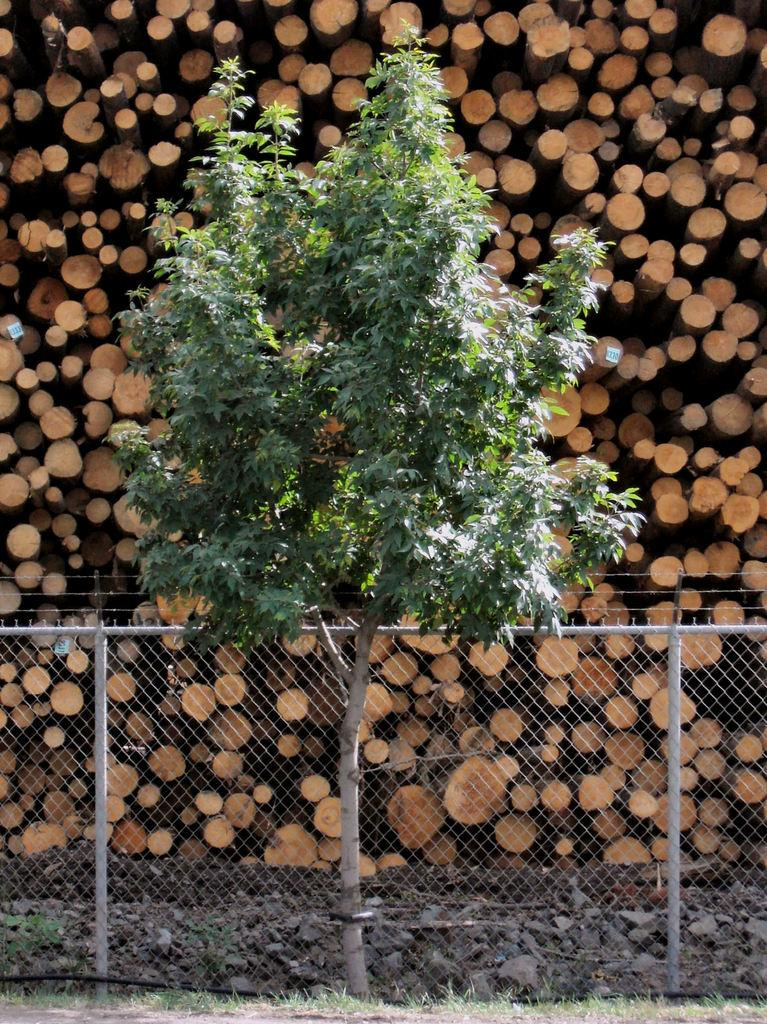What type of structure can be seen in the image? There is fencing in the image. What is the color of the grass in the image? There is green grass in the image. What type of plant is present in the image? There is a tree in the image. What can be seen in the background of the image? In the background of the image, there are logs of wood. What is the opinion of the tree in the image? Trees do not have opinions, so this question cannot be answered. Is there a fight happening in the image? There is no indication of a fight in the image; it features fencing, green grass, a tree, and logs of wood in the background. 